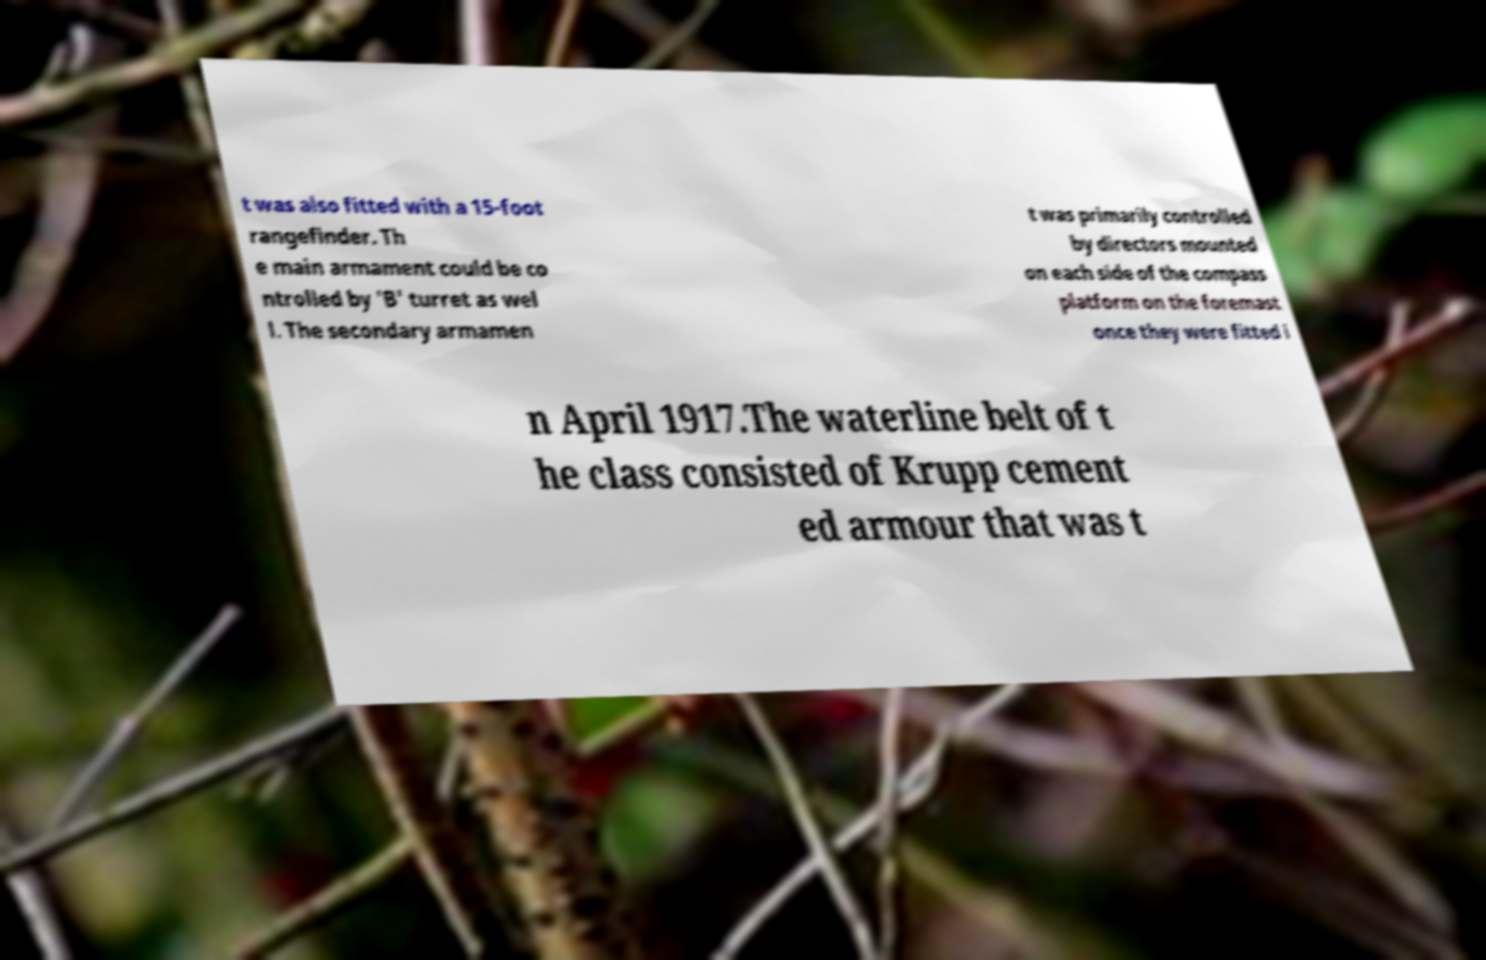Can you read and provide the text displayed in the image?This photo seems to have some interesting text. Can you extract and type it out for me? t was also fitted with a 15-foot rangefinder. Th e main armament could be co ntrolled by 'B' turret as wel l. The secondary armamen t was primarily controlled by directors mounted on each side of the compass platform on the foremast once they were fitted i n April 1917.The waterline belt of t he class consisted of Krupp cement ed armour that was t 